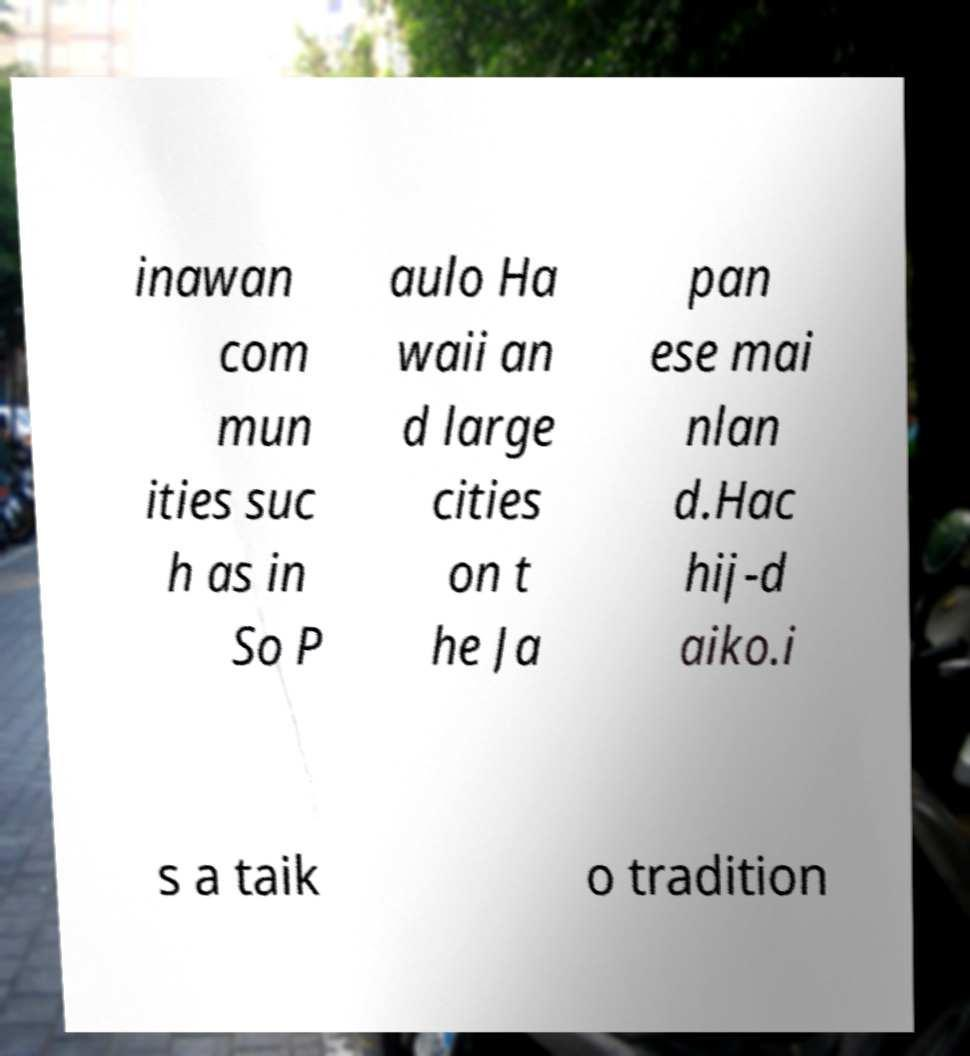There's text embedded in this image that I need extracted. Can you transcribe it verbatim? inawan com mun ities suc h as in So P aulo Ha waii an d large cities on t he Ja pan ese mai nlan d.Hac hij-d aiko.i s a taik o tradition 